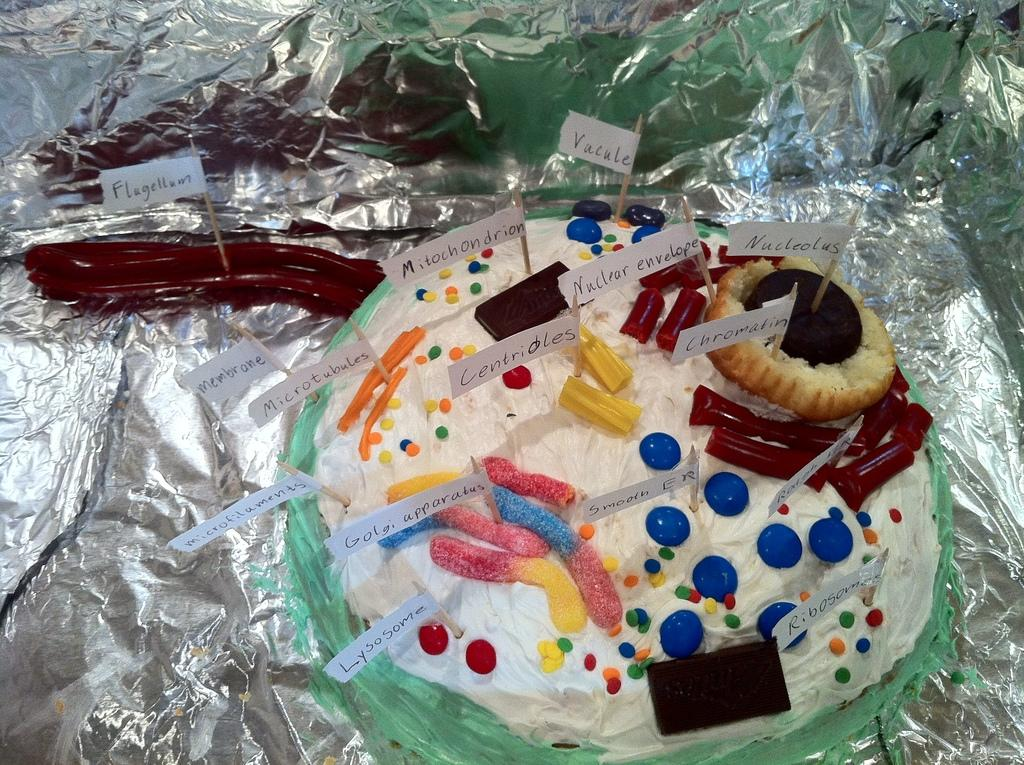What is the main subject of the image? There is a cake in the image. How is the cake placed or wrapped? The cake is on aluminium foil. What can be observed about the cake's appearance? The cake is decorated with colorful things. Can you identify any specific decorations on the cake? Small paper flags are part of the cake's decoration. How many books are stacked on top of the cake in the image? There are no books present in the image; it features a cake decorated with colorful things and small paper flags. 